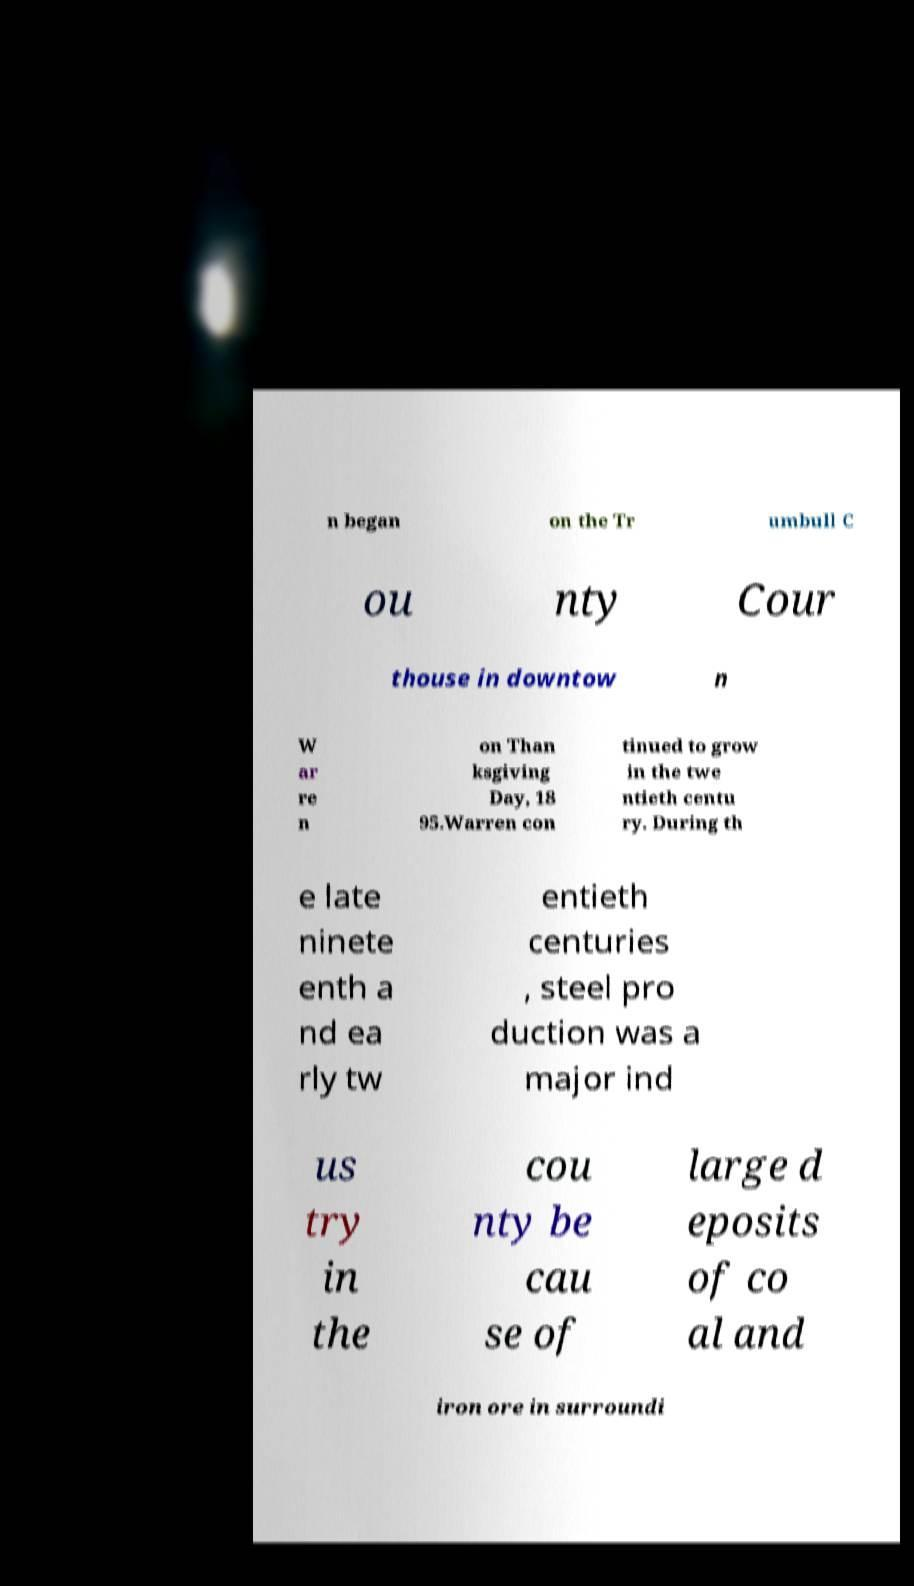Please identify and transcribe the text found in this image. n began on the Tr umbull C ou nty Cour thouse in downtow n W ar re n on Than ksgiving Day, 18 95.Warren con tinued to grow in the twe ntieth centu ry. During th e late ninete enth a nd ea rly tw entieth centuries , steel pro duction was a major ind us try in the cou nty be cau se of large d eposits of co al and iron ore in surroundi 